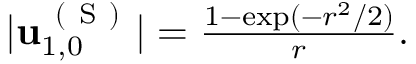<formula> <loc_0><loc_0><loc_500><loc_500>\begin{array} { r } { | u _ { 1 , 0 } ^ { ( S ) } | = \frac { 1 - \exp ( - r ^ { 2 } / 2 ) } { r } . } \end{array}</formula> 